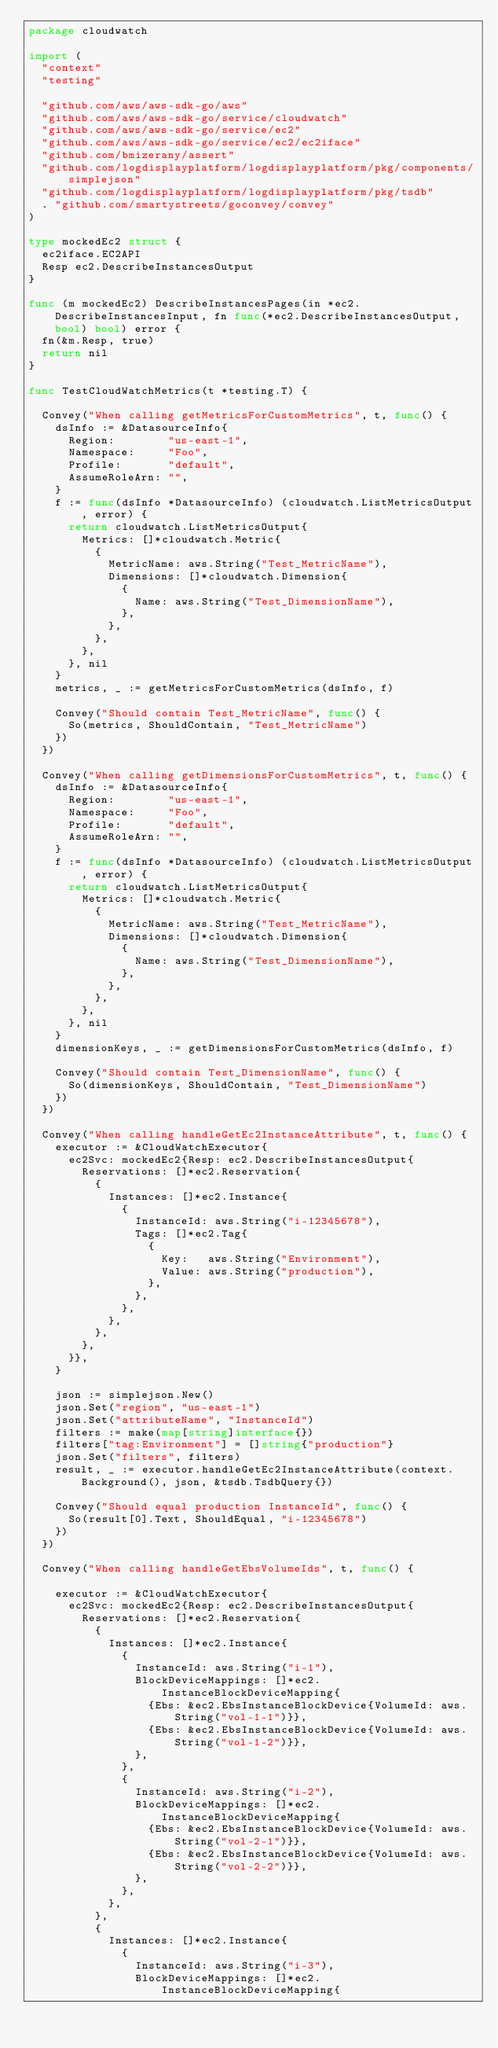Convert code to text. <code><loc_0><loc_0><loc_500><loc_500><_Go_>package cloudwatch

import (
	"context"
	"testing"

	"github.com/aws/aws-sdk-go/aws"
	"github.com/aws/aws-sdk-go/service/cloudwatch"
	"github.com/aws/aws-sdk-go/service/ec2"
	"github.com/aws/aws-sdk-go/service/ec2/ec2iface"
	"github.com/bmizerany/assert"
	"github.com/logdisplayplatform/logdisplayplatform/pkg/components/simplejson"
	"github.com/logdisplayplatform/logdisplayplatform/pkg/tsdb"
	. "github.com/smartystreets/goconvey/convey"
)

type mockedEc2 struct {
	ec2iface.EC2API
	Resp ec2.DescribeInstancesOutput
}

func (m mockedEc2) DescribeInstancesPages(in *ec2.DescribeInstancesInput, fn func(*ec2.DescribeInstancesOutput, bool) bool) error {
	fn(&m.Resp, true)
	return nil
}

func TestCloudWatchMetrics(t *testing.T) {

	Convey("When calling getMetricsForCustomMetrics", t, func() {
		dsInfo := &DatasourceInfo{
			Region:        "us-east-1",
			Namespace:     "Foo",
			Profile:       "default",
			AssumeRoleArn: "",
		}
		f := func(dsInfo *DatasourceInfo) (cloudwatch.ListMetricsOutput, error) {
			return cloudwatch.ListMetricsOutput{
				Metrics: []*cloudwatch.Metric{
					{
						MetricName: aws.String("Test_MetricName"),
						Dimensions: []*cloudwatch.Dimension{
							{
								Name: aws.String("Test_DimensionName"),
							},
						},
					},
				},
			}, nil
		}
		metrics, _ := getMetricsForCustomMetrics(dsInfo, f)

		Convey("Should contain Test_MetricName", func() {
			So(metrics, ShouldContain, "Test_MetricName")
		})
	})

	Convey("When calling getDimensionsForCustomMetrics", t, func() {
		dsInfo := &DatasourceInfo{
			Region:        "us-east-1",
			Namespace:     "Foo",
			Profile:       "default",
			AssumeRoleArn: "",
		}
		f := func(dsInfo *DatasourceInfo) (cloudwatch.ListMetricsOutput, error) {
			return cloudwatch.ListMetricsOutput{
				Metrics: []*cloudwatch.Metric{
					{
						MetricName: aws.String("Test_MetricName"),
						Dimensions: []*cloudwatch.Dimension{
							{
								Name: aws.String("Test_DimensionName"),
							},
						},
					},
				},
			}, nil
		}
		dimensionKeys, _ := getDimensionsForCustomMetrics(dsInfo, f)

		Convey("Should contain Test_DimensionName", func() {
			So(dimensionKeys, ShouldContain, "Test_DimensionName")
		})
	})

	Convey("When calling handleGetEc2InstanceAttribute", t, func() {
		executor := &CloudWatchExecutor{
			ec2Svc: mockedEc2{Resp: ec2.DescribeInstancesOutput{
				Reservations: []*ec2.Reservation{
					{
						Instances: []*ec2.Instance{
							{
								InstanceId: aws.String("i-12345678"),
								Tags: []*ec2.Tag{
									{
										Key:   aws.String("Environment"),
										Value: aws.String("production"),
									},
								},
							},
						},
					},
				},
			}},
		}

		json := simplejson.New()
		json.Set("region", "us-east-1")
		json.Set("attributeName", "InstanceId")
		filters := make(map[string]interface{})
		filters["tag:Environment"] = []string{"production"}
		json.Set("filters", filters)
		result, _ := executor.handleGetEc2InstanceAttribute(context.Background(), json, &tsdb.TsdbQuery{})

		Convey("Should equal production InstanceId", func() {
			So(result[0].Text, ShouldEqual, "i-12345678")
		})
	})

	Convey("When calling handleGetEbsVolumeIds", t, func() {

		executor := &CloudWatchExecutor{
			ec2Svc: mockedEc2{Resp: ec2.DescribeInstancesOutput{
				Reservations: []*ec2.Reservation{
					{
						Instances: []*ec2.Instance{
							{
								InstanceId: aws.String("i-1"),
								BlockDeviceMappings: []*ec2.InstanceBlockDeviceMapping{
									{Ebs: &ec2.EbsInstanceBlockDevice{VolumeId: aws.String("vol-1-1")}},
									{Ebs: &ec2.EbsInstanceBlockDevice{VolumeId: aws.String("vol-1-2")}},
								},
							},
							{
								InstanceId: aws.String("i-2"),
								BlockDeviceMappings: []*ec2.InstanceBlockDeviceMapping{
									{Ebs: &ec2.EbsInstanceBlockDevice{VolumeId: aws.String("vol-2-1")}},
									{Ebs: &ec2.EbsInstanceBlockDevice{VolumeId: aws.String("vol-2-2")}},
								},
							},
						},
					},
					{
						Instances: []*ec2.Instance{
							{
								InstanceId: aws.String("i-3"),
								BlockDeviceMappings: []*ec2.InstanceBlockDeviceMapping{</code> 